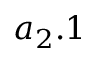<formula> <loc_0><loc_0><loc_500><loc_500>{ a } _ { 2 } . 1</formula> 